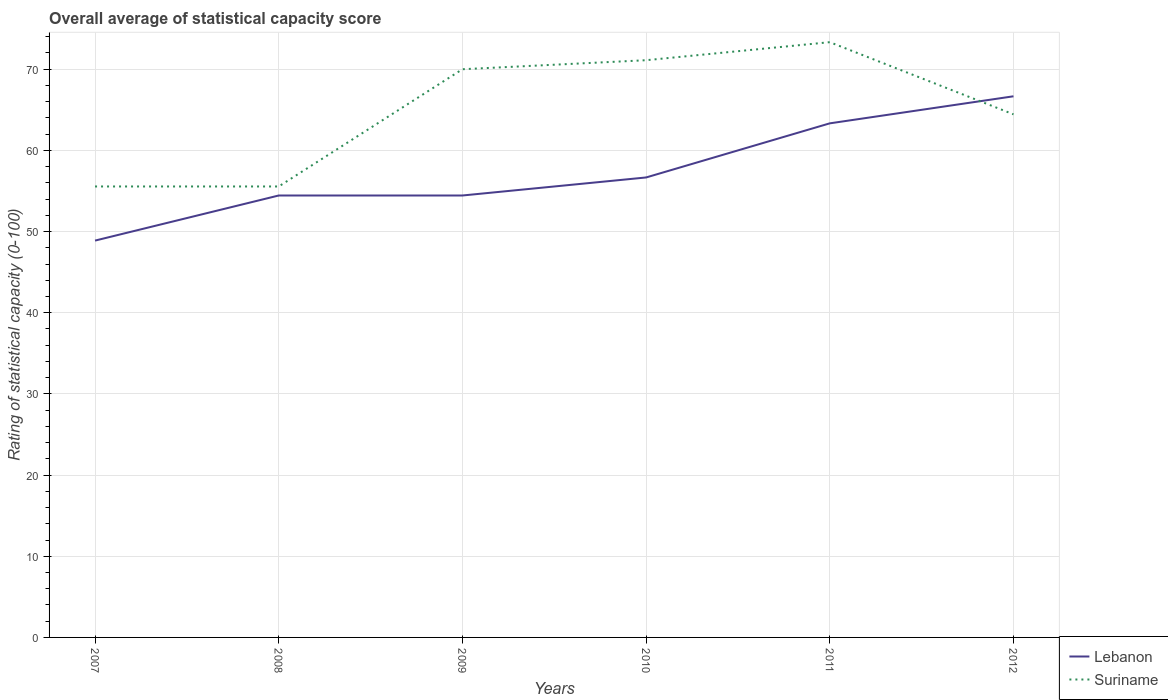How many different coloured lines are there?
Provide a succinct answer. 2. Is the number of lines equal to the number of legend labels?
Your answer should be compact. Yes. Across all years, what is the maximum rating of statistical capacity in Lebanon?
Your response must be concise. 48.89. What is the total rating of statistical capacity in Suriname in the graph?
Give a very brief answer. -14.44. What is the difference between the highest and the second highest rating of statistical capacity in Lebanon?
Provide a short and direct response. 17.78. Is the rating of statistical capacity in Lebanon strictly greater than the rating of statistical capacity in Suriname over the years?
Give a very brief answer. No. How many lines are there?
Provide a succinct answer. 2. How many years are there in the graph?
Offer a terse response. 6. Are the values on the major ticks of Y-axis written in scientific E-notation?
Offer a very short reply. No. Where does the legend appear in the graph?
Your answer should be very brief. Bottom right. How are the legend labels stacked?
Give a very brief answer. Vertical. What is the title of the graph?
Your response must be concise. Overall average of statistical capacity score. What is the label or title of the X-axis?
Give a very brief answer. Years. What is the label or title of the Y-axis?
Ensure brevity in your answer.  Rating of statistical capacity (0-100). What is the Rating of statistical capacity (0-100) in Lebanon in 2007?
Provide a short and direct response. 48.89. What is the Rating of statistical capacity (0-100) in Suriname in 2007?
Provide a short and direct response. 55.56. What is the Rating of statistical capacity (0-100) in Lebanon in 2008?
Make the answer very short. 54.44. What is the Rating of statistical capacity (0-100) in Suriname in 2008?
Keep it short and to the point. 55.56. What is the Rating of statistical capacity (0-100) of Lebanon in 2009?
Provide a succinct answer. 54.44. What is the Rating of statistical capacity (0-100) of Lebanon in 2010?
Make the answer very short. 56.67. What is the Rating of statistical capacity (0-100) in Suriname in 2010?
Provide a short and direct response. 71.11. What is the Rating of statistical capacity (0-100) in Lebanon in 2011?
Provide a succinct answer. 63.33. What is the Rating of statistical capacity (0-100) of Suriname in 2011?
Give a very brief answer. 73.33. What is the Rating of statistical capacity (0-100) of Lebanon in 2012?
Your answer should be very brief. 66.67. What is the Rating of statistical capacity (0-100) in Suriname in 2012?
Your answer should be very brief. 64.44. Across all years, what is the maximum Rating of statistical capacity (0-100) of Lebanon?
Keep it short and to the point. 66.67. Across all years, what is the maximum Rating of statistical capacity (0-100) of Suriname?
Give a very brief answer. 73.33. Across all years, what is the minimum Rating of statistical capacity (0-100) in Lebanon?
Offer a terse response. 48.89. Across all years, what is the minimum Rating of statistical capacity (0-100) of Suriname?
Ensure brevity in your answer.  55.56. What is the total Rating of statistical capacity (0-100) of Lebanon in the graph?
Ensure brevity in your answer.  344.44. What is the total Rating of statistical capacity (0-100) in Suriname in the graph?
Offer a terse response. 390. What is the difference between the Rating of statistical capacity (0-100) in Lebanon in 2007 and that in 2008?
Provide a short and direct response. -5.56. What is the difference between the Rating of statistical capacity (0-100) in Suriname in 2007 and that in 2008?
Your answer should be very brief. 0. What is the difference between the Rating of statistical capacity (0-100) of Lebanon in 2007 and that in 2009?
Your answer should be compact. -5.56. What is the difference between the Rating of statistical capacity (0-100) in Suriname in 2007 and that in 2009?
Offer a very short reply. -14.44. What is the difference between the Rating of statistical capacity (0-100) of Lebanon in 2007 and that in 2010?
Your answer should be very brief. -7.78. What is the difference between the Rating of statistical capacity (0-100) of Suriname in 2007 and that in 2010?
Keep it short and to the point. -15.56. What is the difference between the Rating of statistical capacity (0-100) of Lebanon in 2007 and that in 2011?
Ensure brevity in your answer.  -14.44. What is the difference between the Rating of statistical capacity (0-100) in Suriname in 2007 and that in 2011?
Keep it short and to the point. -17.78. What is the difference between the Rating of statistical capacity (0-100) in Lebanon in 2007 and that in 2012?
Keep it short and to the point. -17.78. What is the difference between the Rating of statistical capacity (0-100) of Suriname in 2007 and that in 2012?
Offer a terse response. -8.89. What is the difference between the Rating of statistical capacity (0-100) in Suriname in 2008 and that in 2009?
Your response must be concise. -14.44. What is the difference between the Rating of statistical capacity (0-100) of Lebanon in 2008 and that in 2010?
Provide a succinct answer. -2.22. What is the difference between the Rating of statistical capacity (0-100) of Suriname in 2008 and that in 2010?
Offer a terse response. -15.56. What is the difference between the Rating of statistical capacity (0-100) of Lebanon in 2008 and that in 2011?
Make the answer very short. -8.89. What is the difference between the Rating of statistical capacity (0-100) in Suriname in 2008 and that in 2011?
Provide a succinct answer. -17.78. What is the difference between the Rating of statistical capacity (0-100) of Lebanon in 2008 and that in 2012?
Give a very brief answer. -12.22. What is the difference between the Rating of statistical capacity (0-100) in Suriname in 2008 and that in 2012?
Ensure brevity in your answer.  -8.89. What is the difference between the Rating of statistical capacity (0-100) of Lebanon in 2009 and that in 2010?
Your answer should be very brief. -2.22. What is the difference between the Rating of statistical capacity (0-100) of Suriname in 2009 and that in 2010?
Provide a short and direct response. -1.11. What is the difference between the Rating of statistical capacity (0-100) in Lebanon in 2009 and that in 2011?
Provide a succinct answer. -8.89. What is the difference between the Rating of statistical capacity (0-100) of Suriname in 2009 and that in 2011?
Your response must be concise. -3.33. What is the difference between the Rating of statistical capacity (0-100) of Lebanon in 2009 and that in 2012?
Your response must be concise. -12.22. What is the difference between the Rating of statistical capacity (0-100) of Suriname in 2009 and that in 2012?
Offer a very short reply. 5.56. What is the difference between the Rating of statistical capacity (0-100) of Lebanon in 2010 and that in 2011?
Keep it short and to the point. -6.67. What is the difference between the Rating of statistical capacity (0-100) in Suriname in 2010 and that in 2011?
Give a very brief answer. -2.22. What is the difference between the Rating of statistical capacity (0-100) of Lebanon in 2010 and that in 2012?
Your answer should be compact. -10. What is the difference between the Rating of statistical capacity (0-100) of Lebanon in 2011 and that in 2012?
Your answer should be compact. -3.33. What is the difference between the Rating of statistical capacity (0-100) in Suriname in 2011 and that in 2012?
Your answer should be very brief. 8.89. What is the difference between the Rating of statistical capacity (0-100) of Lebanon in 2007 and the Rating of statistical capacity (0-100) of Suriname in 2008?
Your response must be concise. -6.67. What is the difference between the Rating of statistical capacity (0-100) of Lebanon in 2007 and the Rating of statistical capacity (0-100) of Suriname in 2009?
Offer a very short reply. -21.11. What is the difference between the Rating of statistical capacity (0-100) in Lebanon in 2007 and the Rating of statistical capacity (0-100) in Suriname in 2010?
Give a very brief answer. -22.22. What is the difference between the Rating of statistical capacity (0-100) in Lebanon in 2007 and the Rating of statistical capacity (0-100) in Suriname in 2011?
Your response must be concise. -24.44. What is the difference between the Rating of statistical capacity (0-100) of Lebanon in 2007 and the Rating of statistical capacity (0-100) of Suriname in 2012?
Make the answer very short. -15.56. What is the difference between the Rating of statistical capacity (0-100) of Lebanon in 2008 and the Rating of statistical capacity (0-100) of Suriname in 2009?
Your response must be concise. -15.56. What is the difference between the Rating of statistical capacity (0-100) in Lebanon in 2008 and the Rating of statistical capacity (0-100) in Suriname in 2010?
Provide a short and direct response. -16.67. What is the difference between the Rating of statistical capacity (0-100) in Lebanon in 2008 and the Rating of statistical capacity (0-100) in Suriname in 2011?
Your answer should be very brief. -18.89. What is the difference between the Rating of statistical capacity (0-100) in Lebanon in 2009 and the Rating of statistical capacity (0-100) in Suriname in 2010?
Ensure brevity in your answer.  -16.67. What is the difference between the Rating of statistical capacity (0-100) of Lebanon in 2009 and the Rating of statistical capacity (0-100) of Suriname in 2011?
Make the answer very short. -18.89. What is the difference between the Rating of statistical capacity (0-100) of Lebanon in 2009 and the Rating of statistical capacity (0-100) of Suriname in 2012?
Your answer should be very brief. -10. What is the difference between the Rating of statistical capacity (0-100) of Lebanon in 2010 and the Rating of statistical capacity (0-100) of Suriname in 2011?
Keep it short and to the point. -16.67. What is the difference between the Rating of statistical capacity (0-100) in Lebanon in 2010 and the Rating of statistical capacity (0-100) in Suriname in 2012?
Your answer should be very brief. -7.78. What is the difference between the Rating of statistical capacity (0-100) of Lebanon in 2011 and the Rating of statistical capacity (0-100) of Suriname in 2012?
Provide a succinct answer. -1.11. What is the average Rating of statistical capacity (0-100) of Lebanon per year?
Your response must be concise. 57.41. In the year 2007, what is the difference between the Rating of statistical capacity (0-100) in Lebanon and Rating of statistical capacity (0-100) in Suriname?
Keep it short and to the point. -6.67. In the year 2008, what is the difference between the Rating of statistical capacity (0-100) in Lebanon and Rating of statistical capacity (0-100) in Suriname?
Provide a short and direct response. -1.11. In the year 2009, what is the difference between the Rating of statistical capacity (0-100) in Lebanon and Rating of statistical capacity (0-100) in Suriname?
Ensure brevity in your answer.  -15.56. In the year 2010, what is the difference between the Rating of statistical capacity (0-100) in Lebanon and Rating of statistical capacity (0-100) in Suriname?
Ensure brevity in your answer.  -14.44. In the year 2011, what is the difference between the Rating of statistical capacity (0-100) in Lebanon and Rating of statistical capacity (0-100) in Suriname?
Offer a terse response. -10. In the year 2012, what is the difference between the Rating of statistical capacity (0-100) in Lebanon and Rating of statistical capacity (0-100) in Suriname?
Offer a terse response. 2.22. What is the ratio of the Rating of statistical capacity (0-100) in Lebanon in 2007 to that in 2008?
Provide a short and direct response. 0.9. What is the ratio of the Rating of statistical capacity (0-100) of Suriname in 2007 to that in 2008?
Your answer should be very brief. 1. What is the ratio of the Rating of statistical capacity (0-100) of Lebanon in 2007 to that in 2009?
Your answer should be compact. 0.9. What is the ratio of the Rating of statistical capacity (0-100) of Suriname in 2007 to that in 2009?
Offer a terse response. 0.79. What is the ratio of the Rating of statistical capacity (0-100) of Lebanon in 2007 to that in 2010?
Your answer should be very brief. 0.86. What is the ratio of the Rating of statistical capacity (0-100) in Suriname in 2007 to that in 2010?
Provide a short and direct response. 0.78. What is the ratio of the Rating of statistical capacity (0-100) in Lebanon in 2007 to that in 2011?
Offer a very short reply. 0.77. What is the ratio of the Rating of statistical capacity (0-100) in Suriname in 2007 to that in 2011?
Ensure brevity in your answer.  0.76. What is the ratio of the Rating of statistical capacity (0-100) in Lebanon in 2007 to that in 2012?
Offer a very short reply. 0.73. What is the ratio of the Rating of statistical capacity (0-100) in Suriname in 2007 to that in 2012?
Keep it short and to the point. 0.86. What is the ratio of the Rating of statistical capacity (0-100) of Suriname in 2008 to that in 2009?
Your response must be concise. 0.79. What is the ratio of the Rating of statistical capacity (0-100) of Lebanon in 2008 to that in 2010?
Provide a succinct answer. 0.96. What is the ratio of the Rating of statistical capacity (0-100) in Suriname in 2008 to that in 2010?
Offer a very short reply. 0.78. What is the ratio of the Rating of statistical capacity (0-100) of Lebanon in 2008 to that in 2011?
Provide a succinct answer. 0.86. What is the ratio of the Rating of statistical capacity (0-100) in Suriname in 2008 to that in 2011?
Make the answer very short. 0.76. What is the ratio of the Rating of statistical capacity (0-100) in Lebanon in 2008 to that in 2012?
Give a very brief answer. 0.82. What is the ratio of the Rating of statistical capacity (0-100) in Suriname in 2008 to that in 2012?
Provide a succinct answer. 0.86. What is the ratio of the Rating of statistical capacity (0-100) in Lebanon in 2009 to that in 2010?
Make the answer very short. 0.96. What is the ratio of the Rating of statistical capacity (0-100) in Suriname in 2009 to that in 2010?
Your answer should be compact. 0.98. What is the ratio of the Rating of statistical capacity (0-100) in Lebanon in 2009 to that in 2011?
Ensure brevity in your answer.  0.86. What is the ratio of the Rating of statistical capacity (0-100) of Suriname in 2009 to that in 2011?
Give a very brief answer. 0.95. What is the ratio of the Rating of statistical capacity (0-100) in Lebanon in 2009 to that in 2012?
Your answer should be very brief. 0.82. What is the ratio of the Rating of statistical capacity (0-100) of Suriname in 2009 to that in 2012?
Ensure brevity in your answer.  1.09. What is the ratio of the Rating of statistical capacity (0-100) of Lebanon in 2010 to that in 2011?
Keep it short and to the point. 0.89. What is the ratio of the Rating of statistical capacity (0-100) in Suriname in 2010 to that in 2011?
Offer a very short reply. 0.97. What is the ratio of the Rating of statistical capacity (0-100) of Suriname in 2010 to that in 2012?
Offer a very short reply. 1.1. What is the ratio of the Rating of statistical capacity (0-100) of Suriname in 2011 to that in 2012?
Provide a short and direct response. 1.14. What is the difference between the highest and the second highest Rating of statistical capacity (0-100) of Lebanon?
Offer a terse response. 3.33. What is the difference between the highest and the second highest Rating of statistical capacity (0-100) in Suriname?
Give a very brief answer. 2.22. What is the difference between the highest and the lowest Rating of statistical capacity (0-100) of Lebanon?
Keep it short and to the point. 17.78. What is the difference between the highest and the lowest Rating of statistical capacity (0-100) of Suriname?
Offer a very short reply. 17.78. 